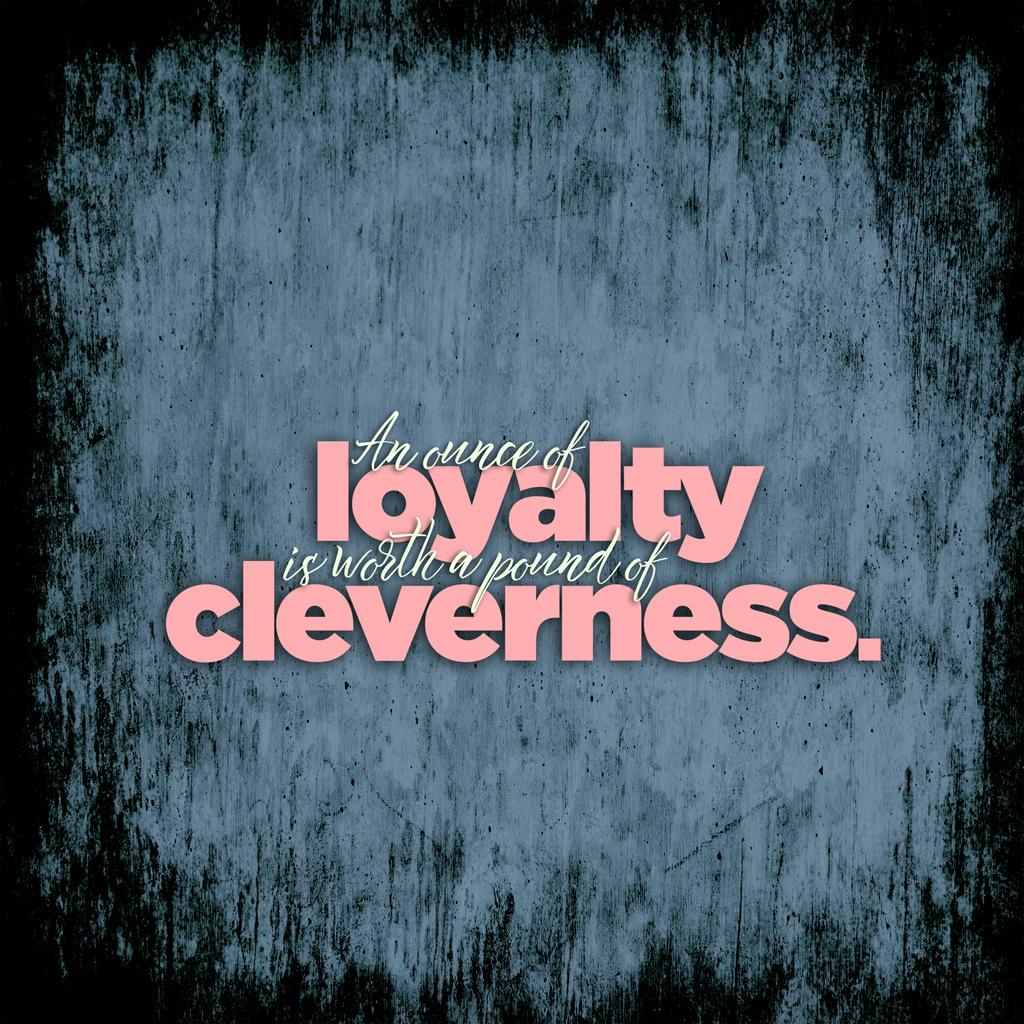<image>
Present a compact description of the photo's key features. A black and grey sign with the message "An ounce of loyalty is worth a pound of cleverness" 